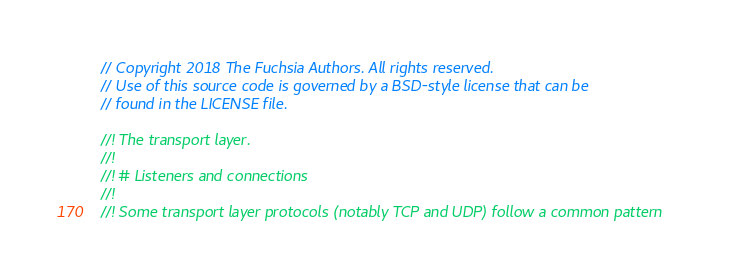<code> <loc_0><loc_0><loc_500><loc_500><_Rust_>// Copyright 2018 The Fuchsia Authors. All rights reserved.
// Use of this source code is governed by a BSD-style license that can be
// found in the LICENSE file.

//! The transport layer.
//!
//! # Listeners and connections
//!
//! Some transport layer protocols (notably TCP and UDP) follow a common pattern</code> 